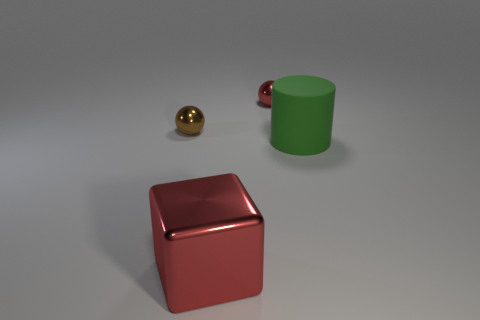Are there any other things that are the same shape as the green rubber thing?
Your response must be concise. No. The brown ball is what size?
Provide a succinct answer. Small. There is a object that is behind the matte object and on the right side of the small brown shiny thing; what shape is it?
Provide a short and direct response. Sphere. What number of red things are small rubber things or large metal objects?
Make the answer very short. 1. Is the size of the thing that is on the left side of the big shiny object the same as the red thing in front of the large cylinder?
Make the answer very short. No. How many things are either tiny metal spheres or red metallic things?
Ensure brevity in your answer.  3. Are there any other small things of the same shape as the small red thing?
Provide a short and direct response. Yes. Are there fewer green cylinders than tiny purple balls?
Your answer should be very brief. No. Do the tiny red shiny object and the large rubber object have the same shape?
Offer a terse response. No. What number of things are green objects or shiny objects behind the large green cylinder?
Give a very brief answer. 3. 